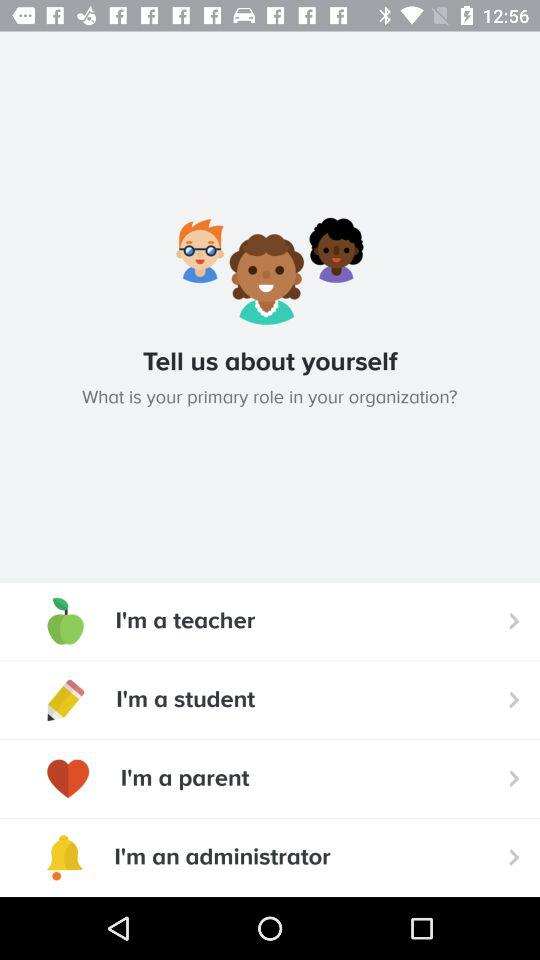How many options are there for the primary role in an organization?
Answer the question using a single word or phrase. 4 